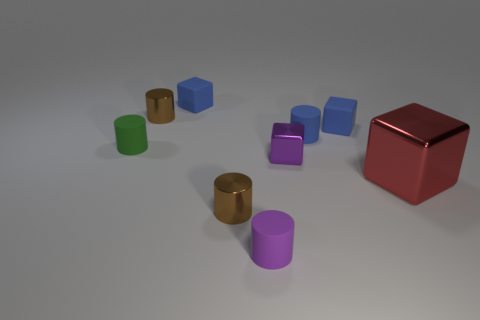Subtract 1 cylinders. How many cylinders are left? 4 Subtract all green cylinders. How many cylinders are left? 4 Subtract all blue matte cylinders. How many cylinders are left? 4 Subtract all cyan blocks. Subtract all yellow cylinders. How many blocks are left? 4 Add 1 tiny yellow rubber cylinders. How many objects exist? 10 Subtract all cylinders. How many objects are left? 4 Subtract all gray metal objects. Subtract all small blue rubber things. How many objects are left? 6 Add 7 brown cylinders. How many brown cylinders are left? 9 Add 6 small blue matte cylinders. How many small blue matte cylinders exist? 7 Subtract 0 yellow blocks. How many objects are left? 9 